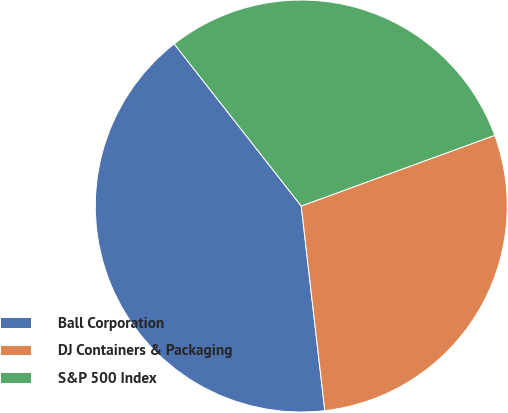Convert chart to OTSL. <chart><loc_0><loc_0><loc_500><loc_500><pie_chart><fcel>Ball Corporation<fcel>DJ Containers & Packaging<fcel>S&P 500 Index<nl><fcel>41.24%<fcel>28.75%<fcel>30.0%<nl></chart> 